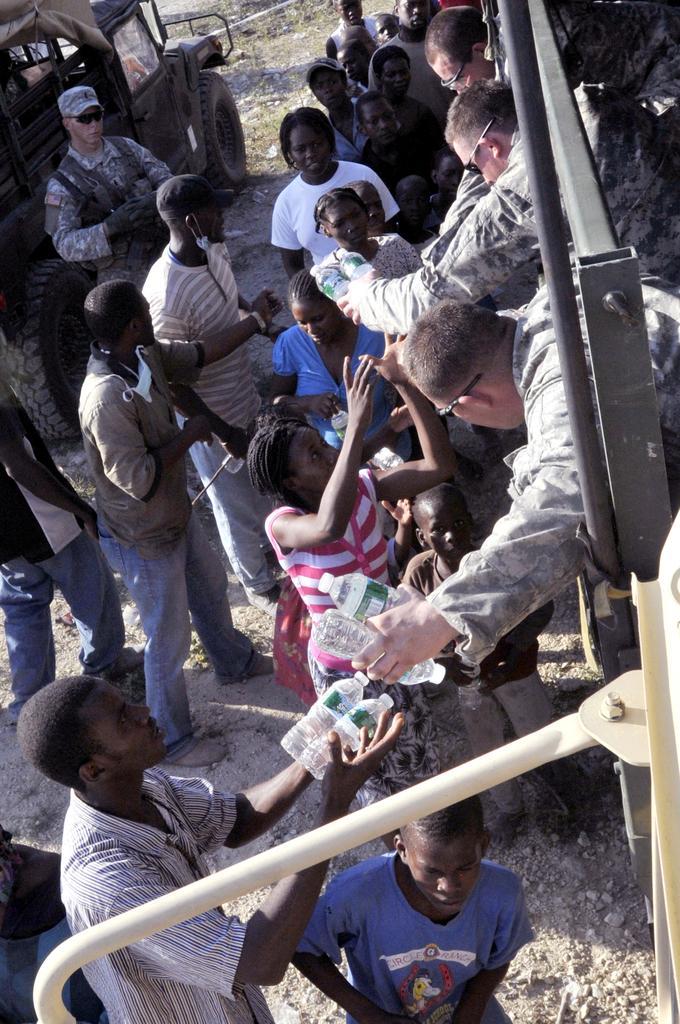Please provide a concise description of this image. In this image we can see many people and few people holding some objects in their hands. There is a vehicles at the left side of the image. 